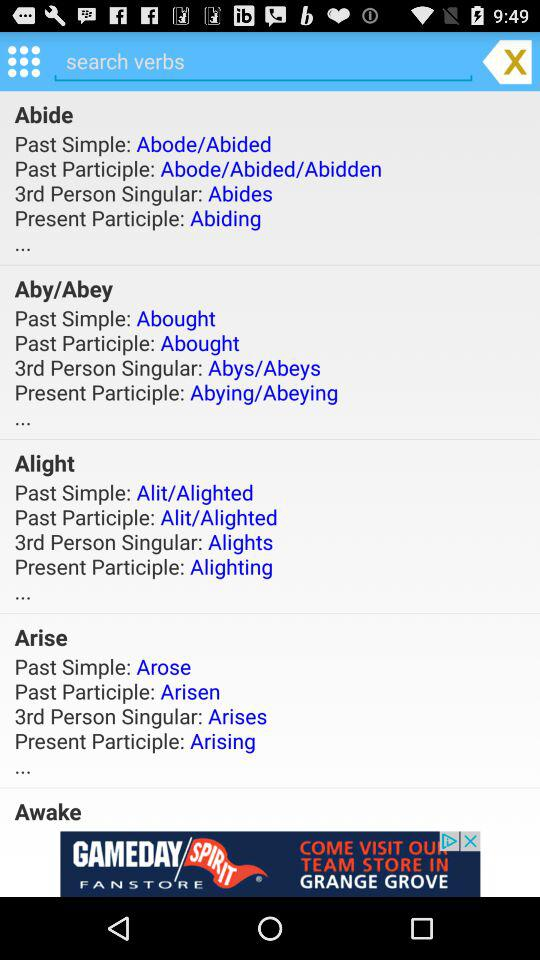What is the past simple of "Awake"?
When the provided information is insufficient, respond with <no answer>. <no answer> 